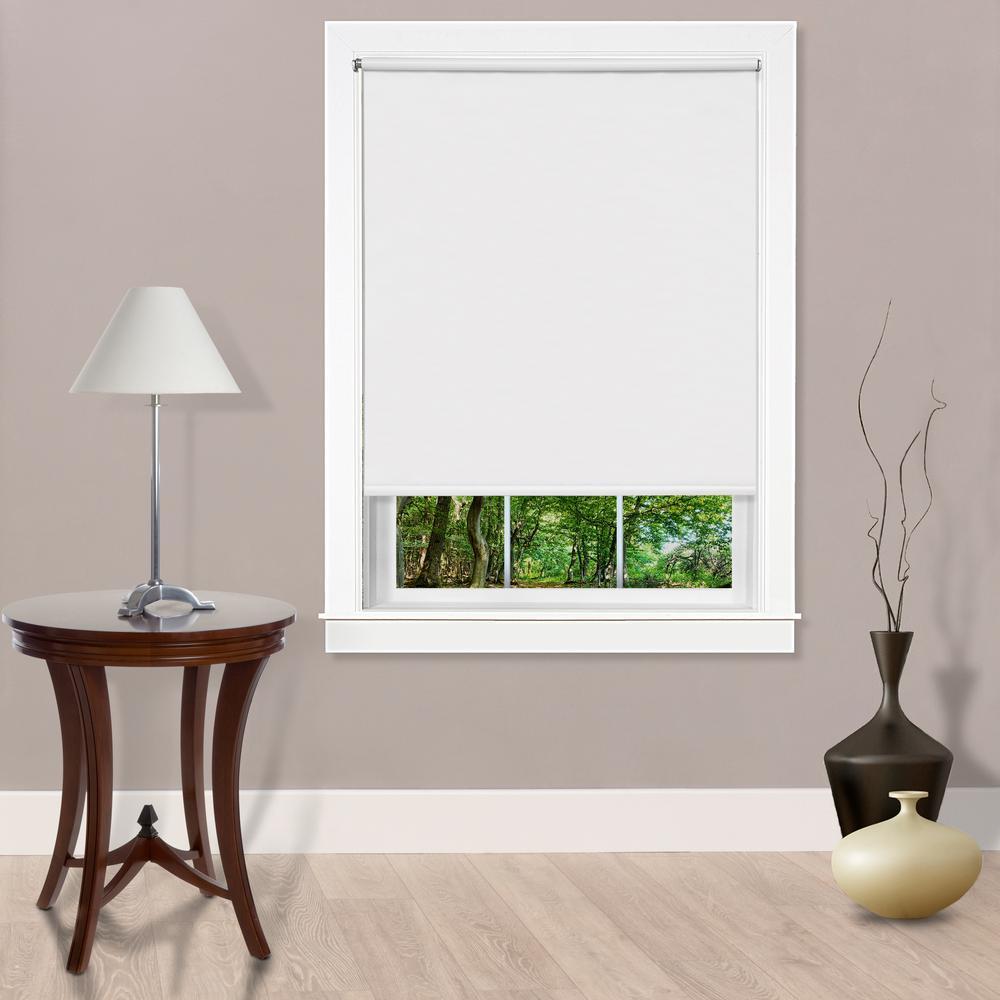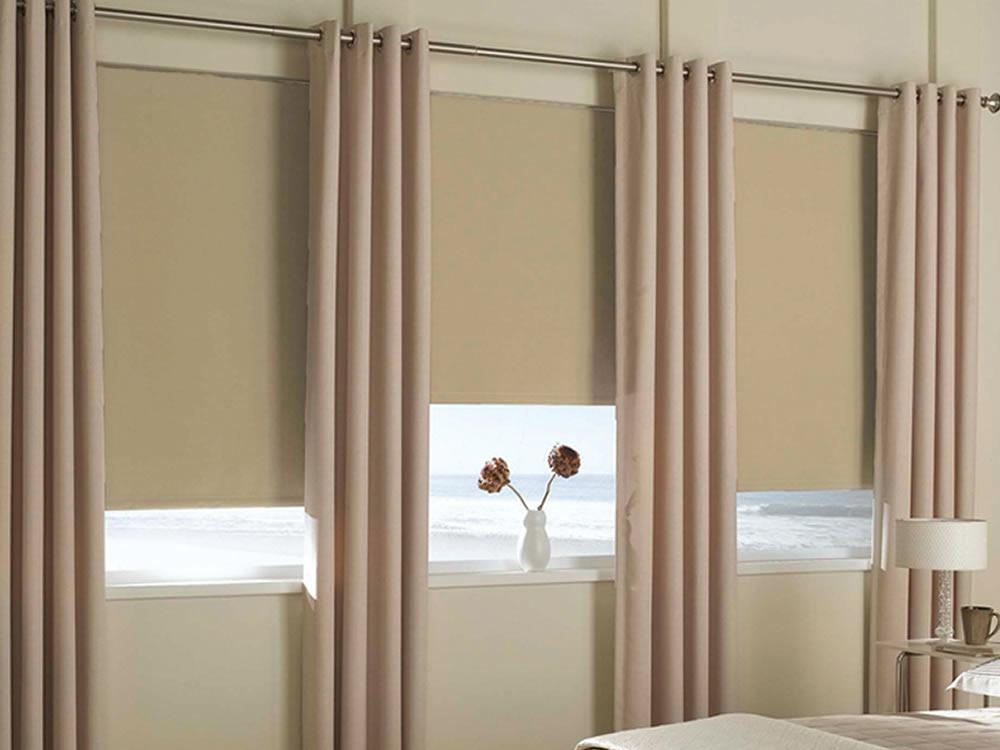The first image is the image on the left, the second image is the image on the right. Analyze the images presented: Is the assertion "There are a total of two windows with white frames shown." valid? Answer yes or no. No. The first image is the image on the left, the second image is the image on the right. Given the left and right images, does the statement "The left and right image contains the same number of blinds." hold true? Answer yes or no. No. 